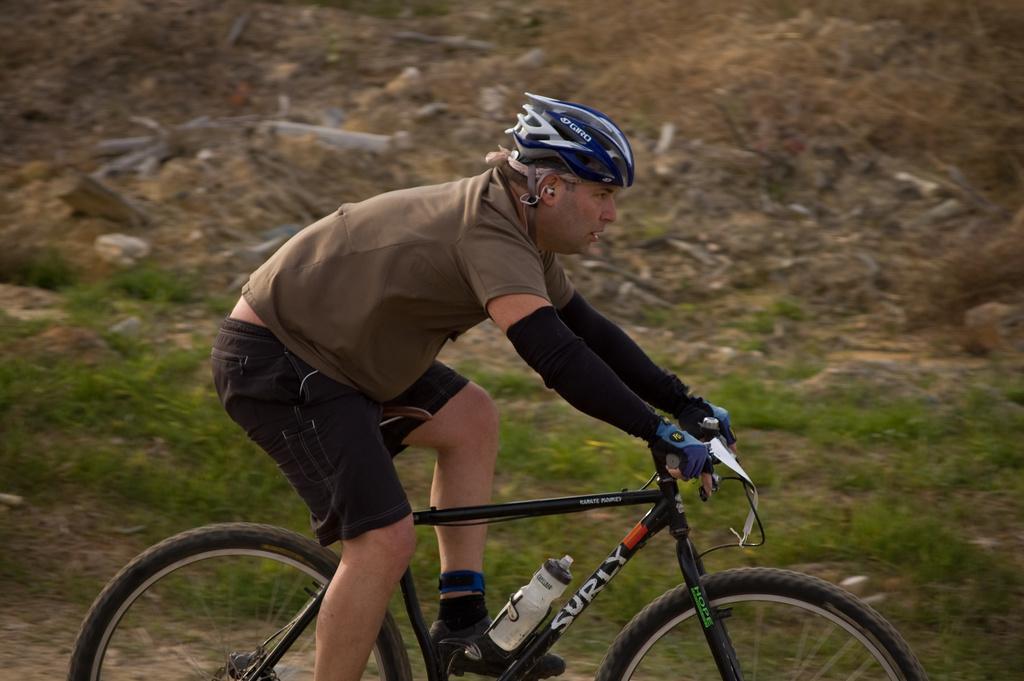Please provide a concise description of this image. In the image we can see a person wearing clothes, socks, shoes, helmet, gloves and the person is riding on the bicycle. Here we can see the grass. 